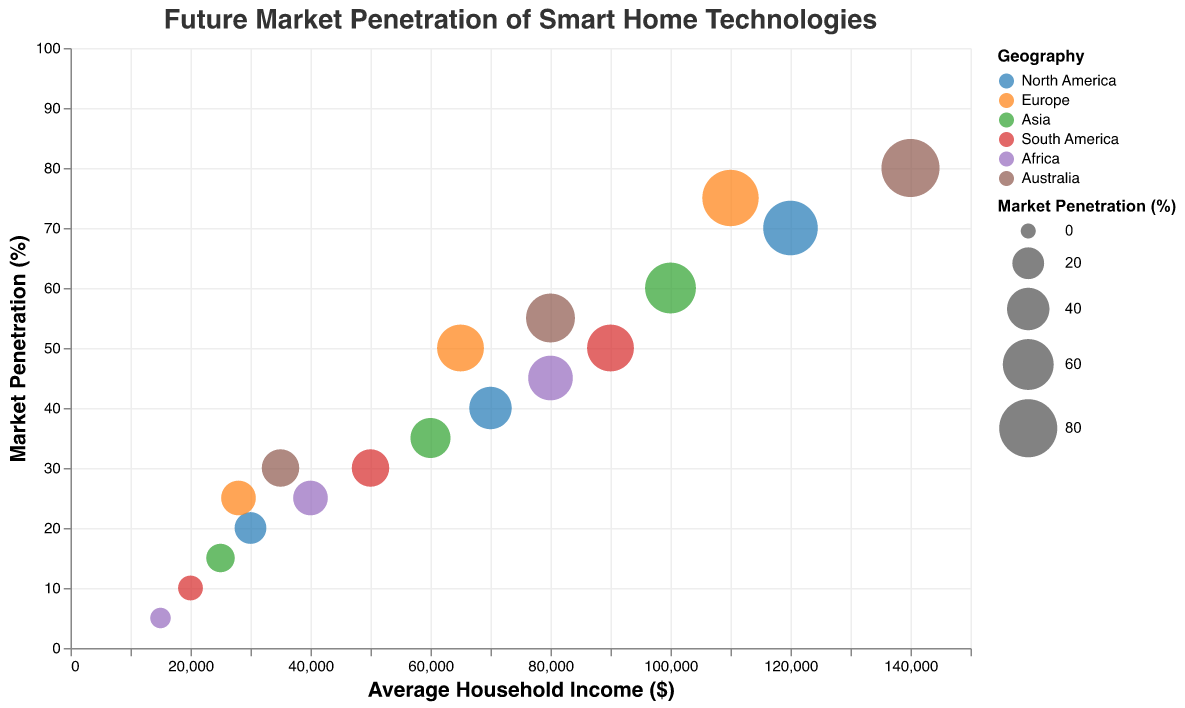What's the title of the chart? The title is usually placed at the top of the chart and in this case reads "Future Market Penetration of Smart Home Technologies."
Answer: Future Market Penetration of Smart Home Technologies Which region has the highest market penetration for high income brackets? Find the bubble with the highest market penetration percentage for the high income bracket, indicated by bubble size and color legend. Australia has the highest market penetration at 80%.
Answer: Australia What is the average household income for middle-income groups in Europe and Asia, and how do they compare? Refer to the bubbles representing middle income in both Europe and Asia. Europe has an average household income of $65,000, while Asia has $60,000.
Answer: Europe has a $5,000 higher average household income Which regions have a low-income bracket market penetration below 20%? Identify the regions with bubble sizes for low-income brackets under the 20% mark. Asia, South America, and Africa are below 20%.
Answer: Asia, South America, Africa How does the market penetration rate for middle-income households in North America compare to Australia? Find the middle-income bubbles in both North America (40%) and Australia (55%) and compare their sizes. Australia has a higher penetration rate.
Answer: Australia has a higher penetration rate Which region has the lowest market penetration for low-income brackets, and what is the corresponding average household income? Look at bubbles for low-income brackets and identify the region with the smallest size, which is Africa with 5% penetration and $15,000 average household income.
Answer: Africa, $15,000 For high-income brackets, compare the market penetration percentages between North America and Europe. Which has higher penetration? Check the bubbles for high-income brackets in North America (70%) and Europe (75%) and compare their sizes. Europe has a higher penetration percentage.
Answer: Europe How many unique regions are displayed in the chart? Use the legend to count distinct color-coded regions. There are six unique regions: North America, Europe, Asia, South America, Africa, and Australia.
Answer: Six What is the market penetration for middle-income households in South America? Look for the bubble that corresponds to the middle-income group in South America and note the size. The penetration is 30%.
Answer: 30% Which region shows the highest market penetration for low-income households, and what does this indicate about the potential market for smart home technologies there? Identify the bubble with the largest size within low-income brackets, which is Australia at 30%. This indicates a potentially more receptive or developed market for smart home technologies among low-income households.
Answer: Australia, indicates a potentially receptive market 